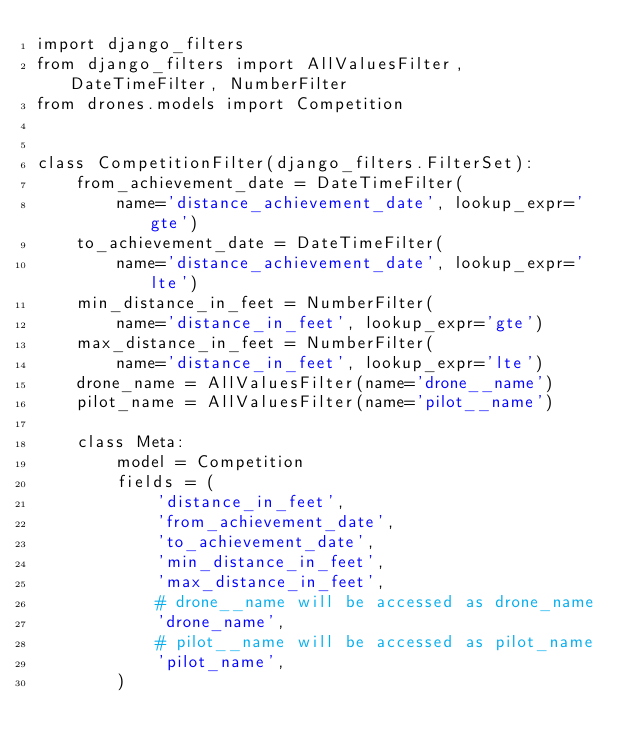Convert code to text. <code><loc_0><loc_0><loc_500><loc_500><_Python_>import django_filters
from django_filters import AllValuesFilter, DateTimeFilter, NumberFilter
from drones.models import Competition


class CompetitionFilter(django_filters.FilterSet):
    from_achievement_date = DateTimeFilter(
        name='distance_achievement_date', lookup_expr='gte')
    to_achievement_date = DateTimeFilter(
        name='distance_achievement_date', lookup_expr='lte')
    min_distance_in_feet = NumberFilter(
        name='distance_in_feet', lookup_expr='gte')
    max_distance_in_feet = NumberFilter(
        name='distance_in_feet', lookup_expr='lte')
    drone_name = AllValuesFilter(name='drone__name')
    pilot_name = AllValuesFilter(name='pilot__name')

    class Meta:
        model = Competition
        fields = (
            'distance_in_feet',
            'from_achievement_date',
            'to_achievement_date',
            'min_distance_in_feet',
            'max_distance_in_feet',
            # drone__name will be accessed as drone_name
            'drone_name',
            # pilot__name will be accessed as pilot_name
            'pilot_name',
        )
</code> 